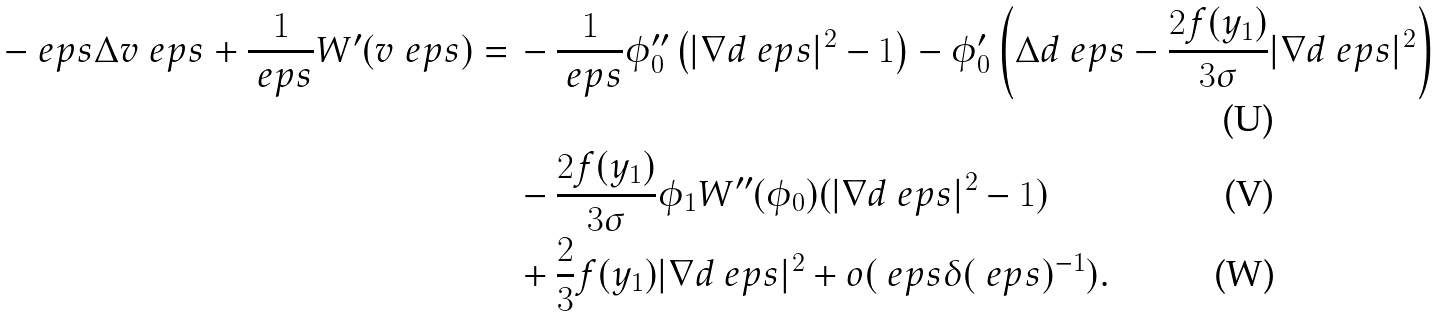Convert formula to latex. <formula><loc_0><loc_0><loc_500><loc_500>- \ e p s \Delta v _ { \ } e p s + \frac { 1 } { \ e p s } W ^ { \prime } ( v _ { \ } e p s ) = \, & - \frac { 1 } { \ e p s } \phi _ { 0 } ^ { \prime \prime } \left ( | \nabla d _ { \ } e p s | ^ { 2 } - 1 \right ) - \phi _ { 0 } ^ { \prime } \left ( \Delta d _ { \ } e p s - \frac { 2 f ( y _ { 1 } ) } { 3 \sigma } | \nabla d _ { \ } e p s | ^ { 2 } \right ) \\ & - \frac { 2 f ( y _ { 1 } ) } { 3 \sigma } \phi _ { 1 } W ^ { \prime \prime } ( \phi _ { 0 } ) ( | \nabla d _ { \ } e p s | ^ { 2 } - 1 ) \\ & + \frac { 2 } { 3 } f ( y _ { 1 } ) | \nabla d _ { \ } e p s | ^ { 2 } + o ( \ e p s \delta ( \ e p s ) ^ { - 1 } ) .</formula> 